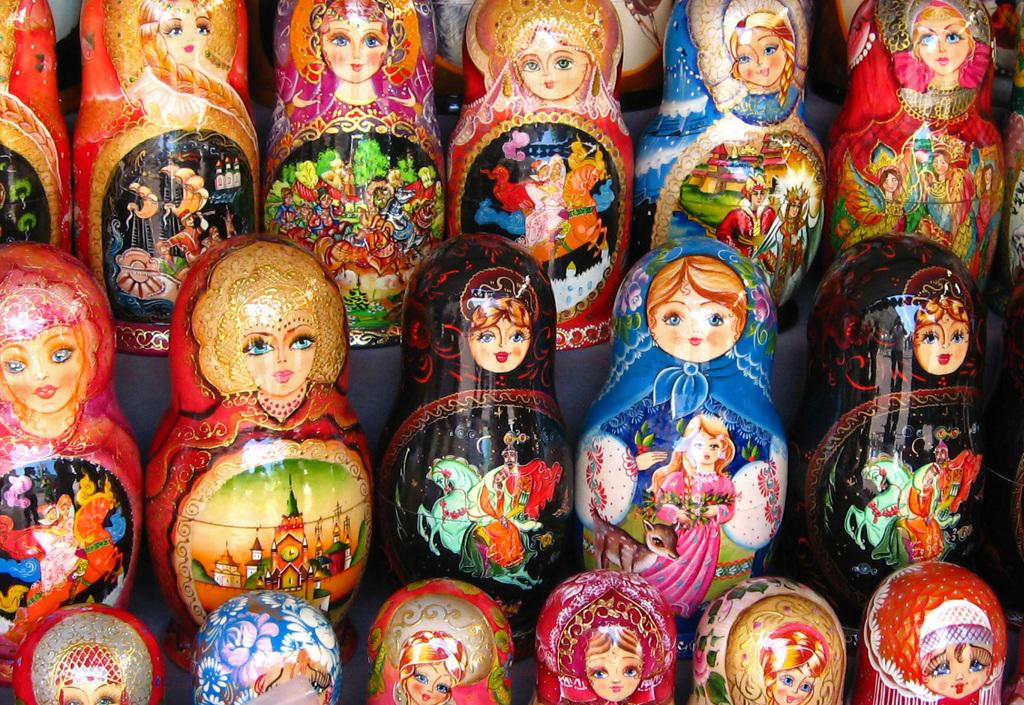What objects are on the table in the image? There are dolls on the table in the image. How many dolls are visible on the table? The number of dolls is not specified in the facts, so we cannot determine the exact number. What might the dolls be used for or represent? The purpose or representation of the dolls is not mentioned in the facts, so we cannot determine their intended use or meaning. What type of girls can be seen crushing the dolls in the image? There are no girls present in the image, and the dolls are not being crushed. 